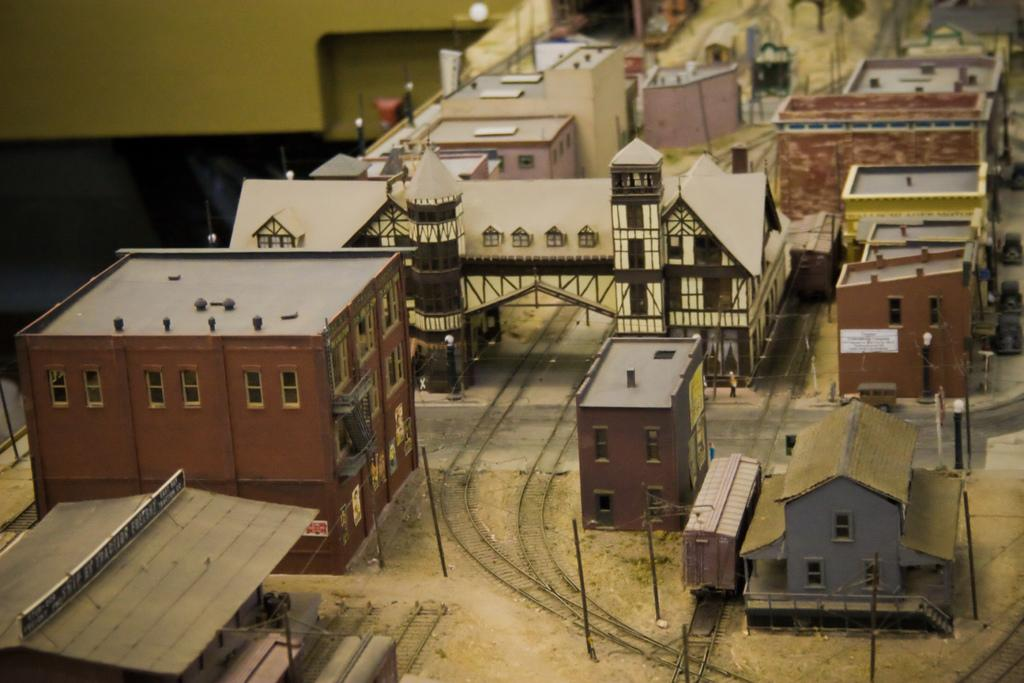What is the main subject of the image? The main subject of the image is a train on a railway track. Are there any other structures or objects in the image? Yes, there are depictions of buildings in the image. What can be seen on the backside of the image? There is a wall visible on the backside of the image. What type of skirt is the train wearing in the image? Trains do not wear skirts, as they are inanimate objects. The question is not relevant to the image. 